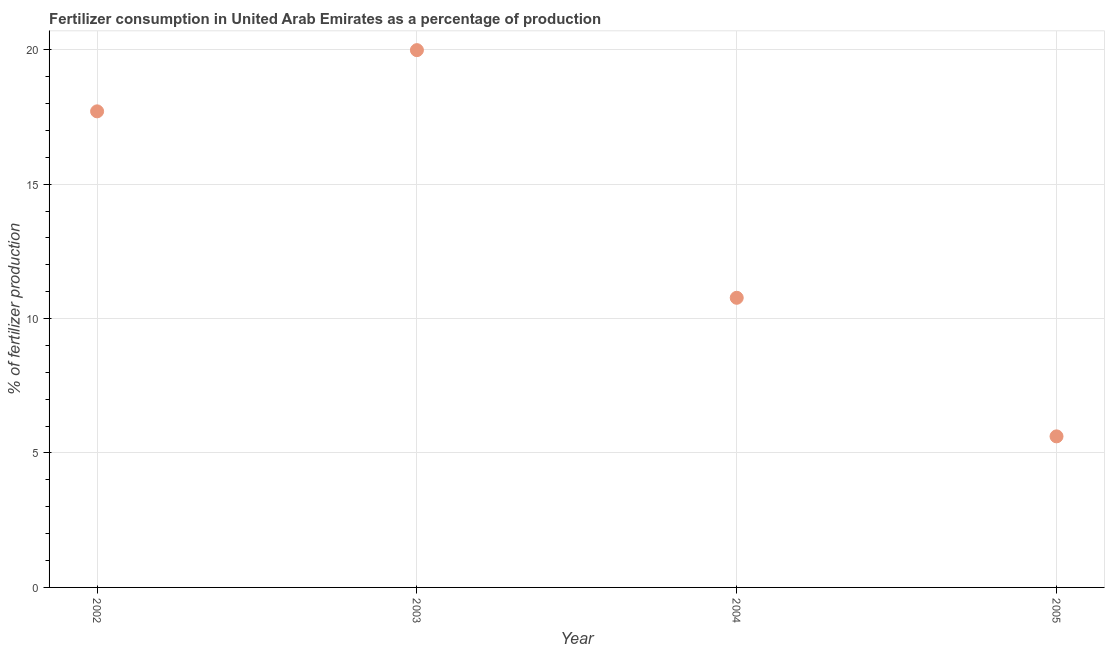What is the amount of fertilizer consumption in 2004?
Make the answer very short. 10.77. Across all years, what is the maximum amount of fertilizer consumption?
Give a very brief answer. 19.98. Across all years, what is the minimum amount of fertilizer consumption?
Your response must be concise. 5.62. In which year was the amount of fertilizer consumption minimum?
Ensure brevity in your answer.  2005. What is the sum of the amount of fertilizer consumption?
Ensure brevity in your answer.  54.08. What is the difference between the amount of fertilizer consumption in 2003 and 2004?
Offer a very short reply. 9.21. What is the average amount of fertilizer consumption per year?
Ensure brevity in your answer.  13.52. What is the median amount of fertilizer consumption?
Make the answer very short. 14.24. What is the ratio of the amount of fertilizer consumption in 2002 to that in 2003?
Offer a very short reply. 0.89. What is the difference between the highest and the second highest amount of fertilizer consumption?
Ensure brevity in your answer.  2.28. What is the difference between the highest and the lowest amount of fertilizer consumption?
Your answer should be compact. 14.37. How many dotlines are there?
Give a very brief answer. 1. How many years are there in the graph?
Give a very brief answer. 4. What is the difference between two consecutive major ticks on the Y-axis?
Your response must be concise. 5. Are the values on the major ticks of Y-axis written in scientific E-notation?
Offer a terse response. No. Does the graph contain grids?
Your answer should be compact. Yes. What is the title of the graph?
Offer a very short reply. Fertilizer consumption in United Arab Emirates as a percentage of production. What is the label or title of the X-axis?
Ensure brevity in your answer.  Year. What is the label or title of the Y-axis?
Make the answer very short. % of fertilizer production. What is the % of fertilizer production in 2002?
Offer a terse response. 17.71. What is the % of fertilizer production in 2003?
Your answer should be very brief. 19.98. What is the % of fertilizer production in 2004?
Offer a very short reply. 10.77. What is the % of fertilizer production in 2005?
Keep it short and to the point. 5.62. What is the difference between the % of fertilizer production in 2002 and 2003?
Your answer should be very brief. -2.28. What is the difference between the % of fertilizer production in 2002 and 2004?
Your answer should be very brief. 6.93. What is the difference between the % of fertilizer production in 2002 and 2005?
Offer a very short reply. 12.09. What is the difference between the % of fertilizer production in 2003 and 2004?
Your response must be concise. 9.21. What is the difference between the % of fertilizer production in 2003 and 2005?
Provide a short and direct response. 14.37. What is the difference between the % of fertilizer production in 2004 and 2005?
Offer a terse response. 5.15. What is the ratio of the % of fertilizer production in 2002 to that in 2003?
Offer a terse response. 0.89. What is the ratio of the % of fertilizer production in 2002 to that in 2004?
Your answer should be compact. 1.64. What is the ratio of the % of fertilizer production in 2002 to that in 2005?
Give a very brief answer. 3.15. What is the ratio of the % of fertilizer production in 2003 to that in 2004?
Offer a very short reply. 1.85. What is the ratio of the % of fertilizer production in 2003 to that in 2005?
Give a very brief answer. 3.56. What is the ratio of the % of fertilizer production in 2004 to that in 2005?
Provide a succinct answer. 1.92. 